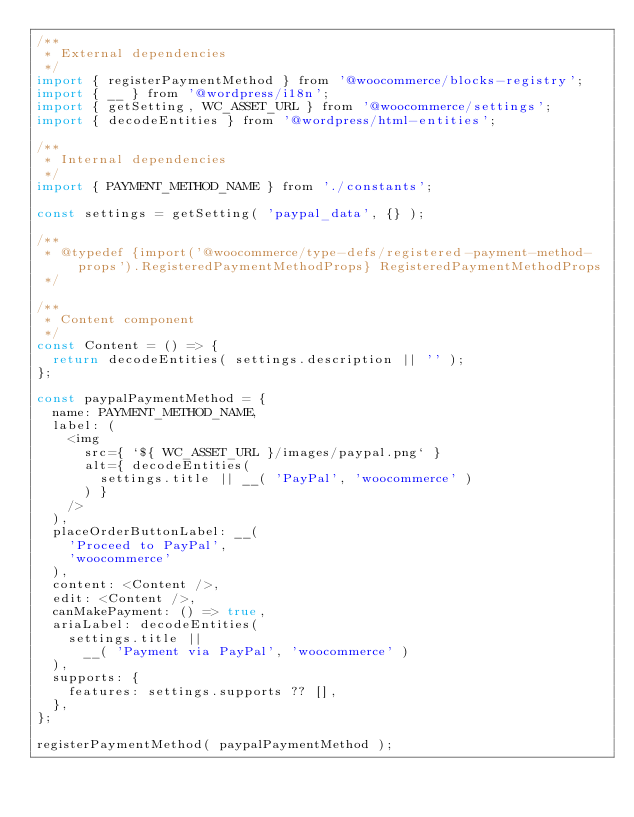Convert code to text. <code><loc_0><loc_0><loc_500><loc_500><_JavaScript_>/**
 * External dependencies
 */
import { registerPaymentMethod } from '@woocommerce/blocks-registry';
import { __ } from '@wordpress/i18n';
import { getSetting, WC_ASSET_URL } from '@woocommerce/settings';
import { decodeEntities } from '@wordpress/html-entities';

/**
 * Internal dependencies
 */
import { PAYMENT_METHOD_NAME } from './constants';

const settings = getSetting( 'paypal_data', {} );

/**
 * @typedef {import('@woocommerce/type-defs/registered-payment-method-props').RegisteredPaymentMethodProps} RegisteredPaymentMethodProps
 */

/**
 * Content component
 */
const Content = () => {
	return decodeEntities( settings.description || '' );
};

const paypalPaymentMethod = {
	name: PAYMENT_METHOD_NAME,
	label: (
		<img
			src={ `${ WC_ASSET_URL }/images/paypal.png` }
			alt={ decodeEntities(
				settings.title || __( 'PayPal', 'woocommerce' )
			) }
		/>
	),
	placeOrderButtonLabel: __(
		'Proceed to PayPal',
		'woocommerce'
	),
	content: <Content />,
	edit: <Content />,
	canMakePayment: () => true,
	ariaLabel: decodeEntities(
		settings.title ||
			__( 'Payment via PayPal', 'woocommerce' )
	),
	supports: {
		features: settings.supports ?? [],
	},
};

registerPaymentMethod( paypalPaymentMethod );
</code> 